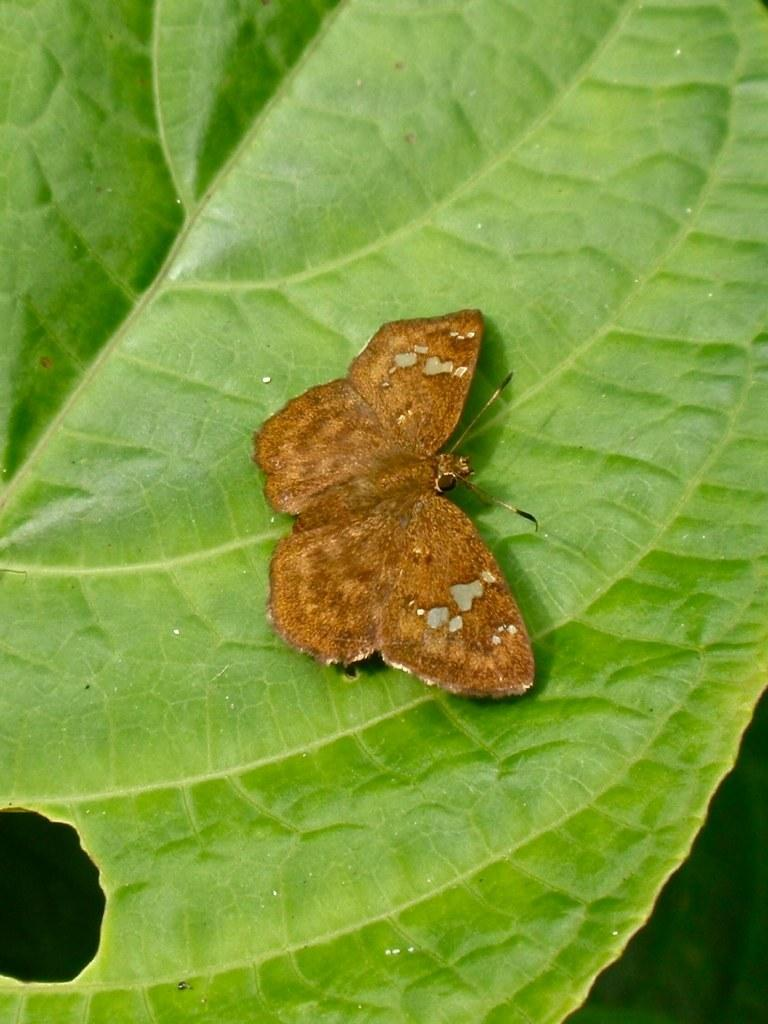What is the main subject of the image? There is a butterfly in the image. Where is the butterfly located? The butterfly is on a leaf. What type of game is being played in the image? There is no game being played in the image; it features a butterfly on a leaf. What is the butterfly eating for breakfast in the image? There is no indication of the butterfly eating breakfast in the image, as butterflies do not consume traditional breakfast foods. 